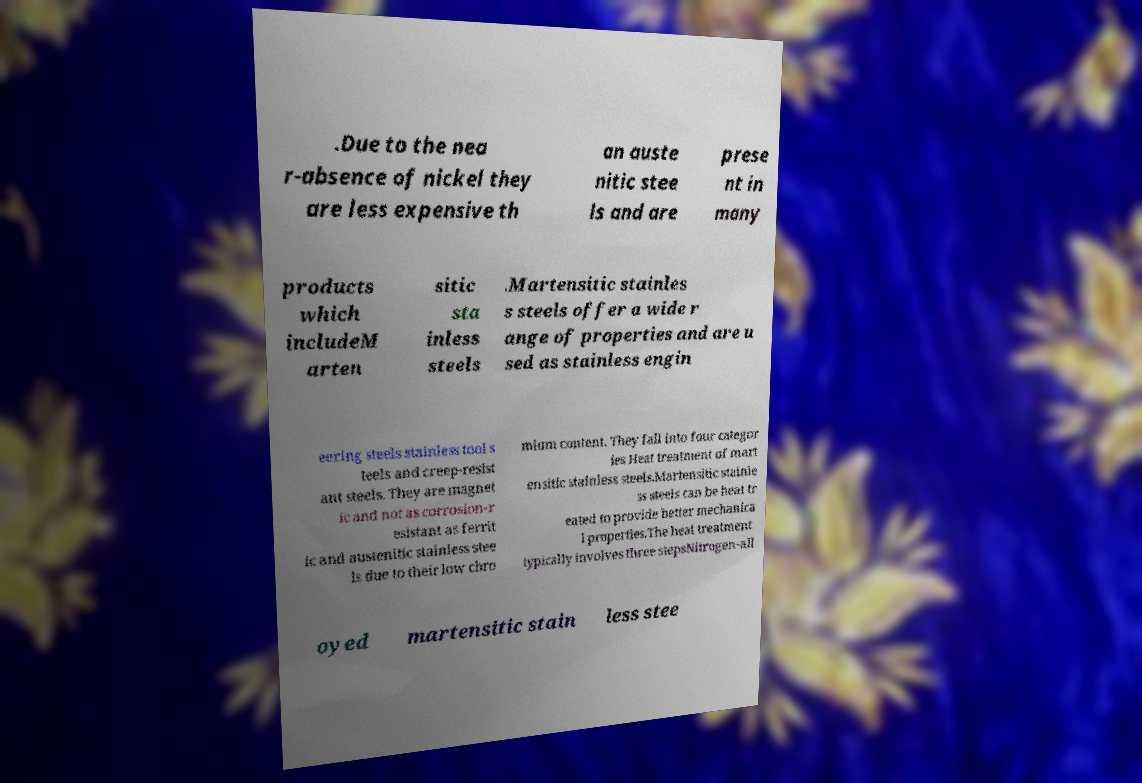There's text embedded in this image that I need extracted. Can you transcribe it verbatim? .Due to the nea r-absence of nickel they are less expensive th an auste nitic stee ls and are prese nt in many products which includeM arten sitic sta inless steels .Martensitic stainles s steels offer a wide r ange of properties and are u sed as stainless engin eering steels stainless tool s teels and creep-resist ant steels. They are magnet ic and not as corrosion-r esistant as ferrit ic and austenitic stainless stee ls due to their low chro mium content. They fall into four categor ies Heat treatment of mart ensitic stainless steels.Martensitic stainle ss steels can be heat tr eated to provide better mechanica l properties.The heat treatment typically involves three stepsNitrogen-all oyed martensitic stain less stee 